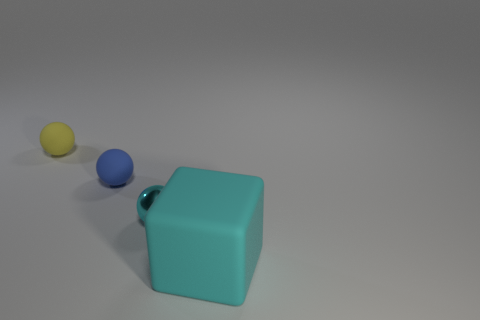There is a rubber object that is to the right of the small cyan object; does it have the same color as the tiny metal thing?
Offer a terse response. Yes. What is the color of the other small rubber object that is the same shape as the yellow thing?
Your response must be concise. Blue. What material is the object that is behind the block and in front of the blue object?
Offer a very short reply. Metal. What is the small cyan thing made of?
Keep it short and to the point. Metal. What number of large objects are either red matte blocks or cyan cubes?
Offer a very short reply. 1. Does the rubber thing that is in front of the tiny cyan metallic object have the same color as the small ball that is in front of the tiny blue object?
Give a very brief answer. Yes. What number of other objects are the same color as the shiny object?
Ensure brevity in your answer.  1. How many yellow objects are small rubber balls or big cubes?
Your response must be concise. 1. Does the big cyan rubber thing have the same shape as the cyan thing that is left of the cyan cube?
Ensure brevity in your answer.  No. What is the shape of the small yellow thing?
Your answer should be very brief. Sphere. 